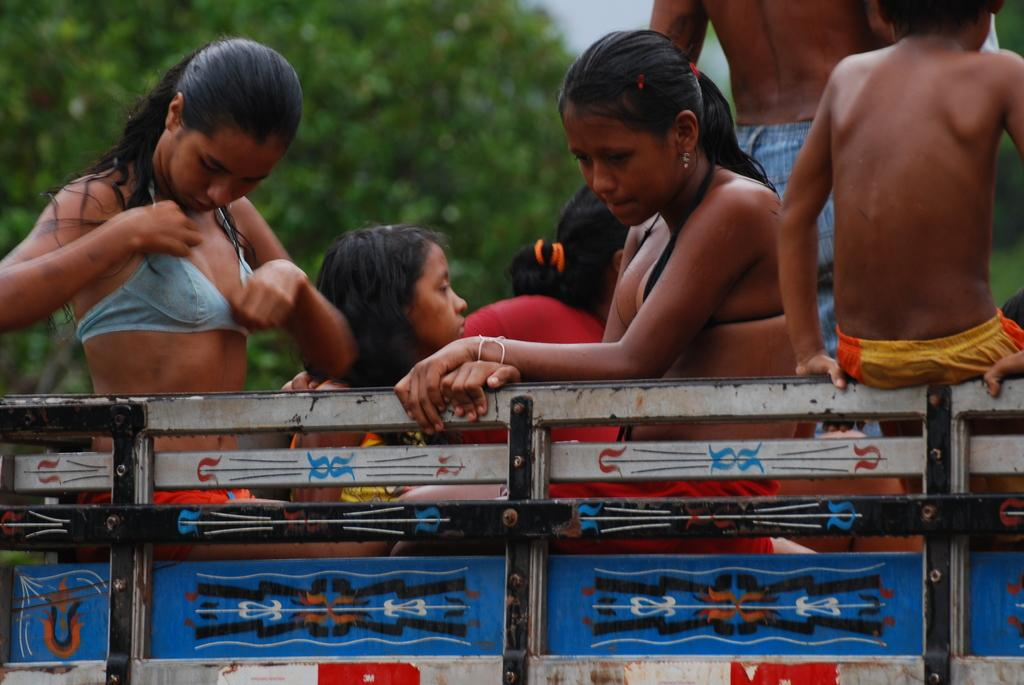What is the main subject in the center of the image? There is a vehicle in the center of the image. What can be seen inside the vehicle? There are people sitting in the vehicle. What type of environment is visible in the background of the image? There are trees visible in the background of the image. What type of beef is being served to the giants in the image? There are no giants or beef present in the image. 